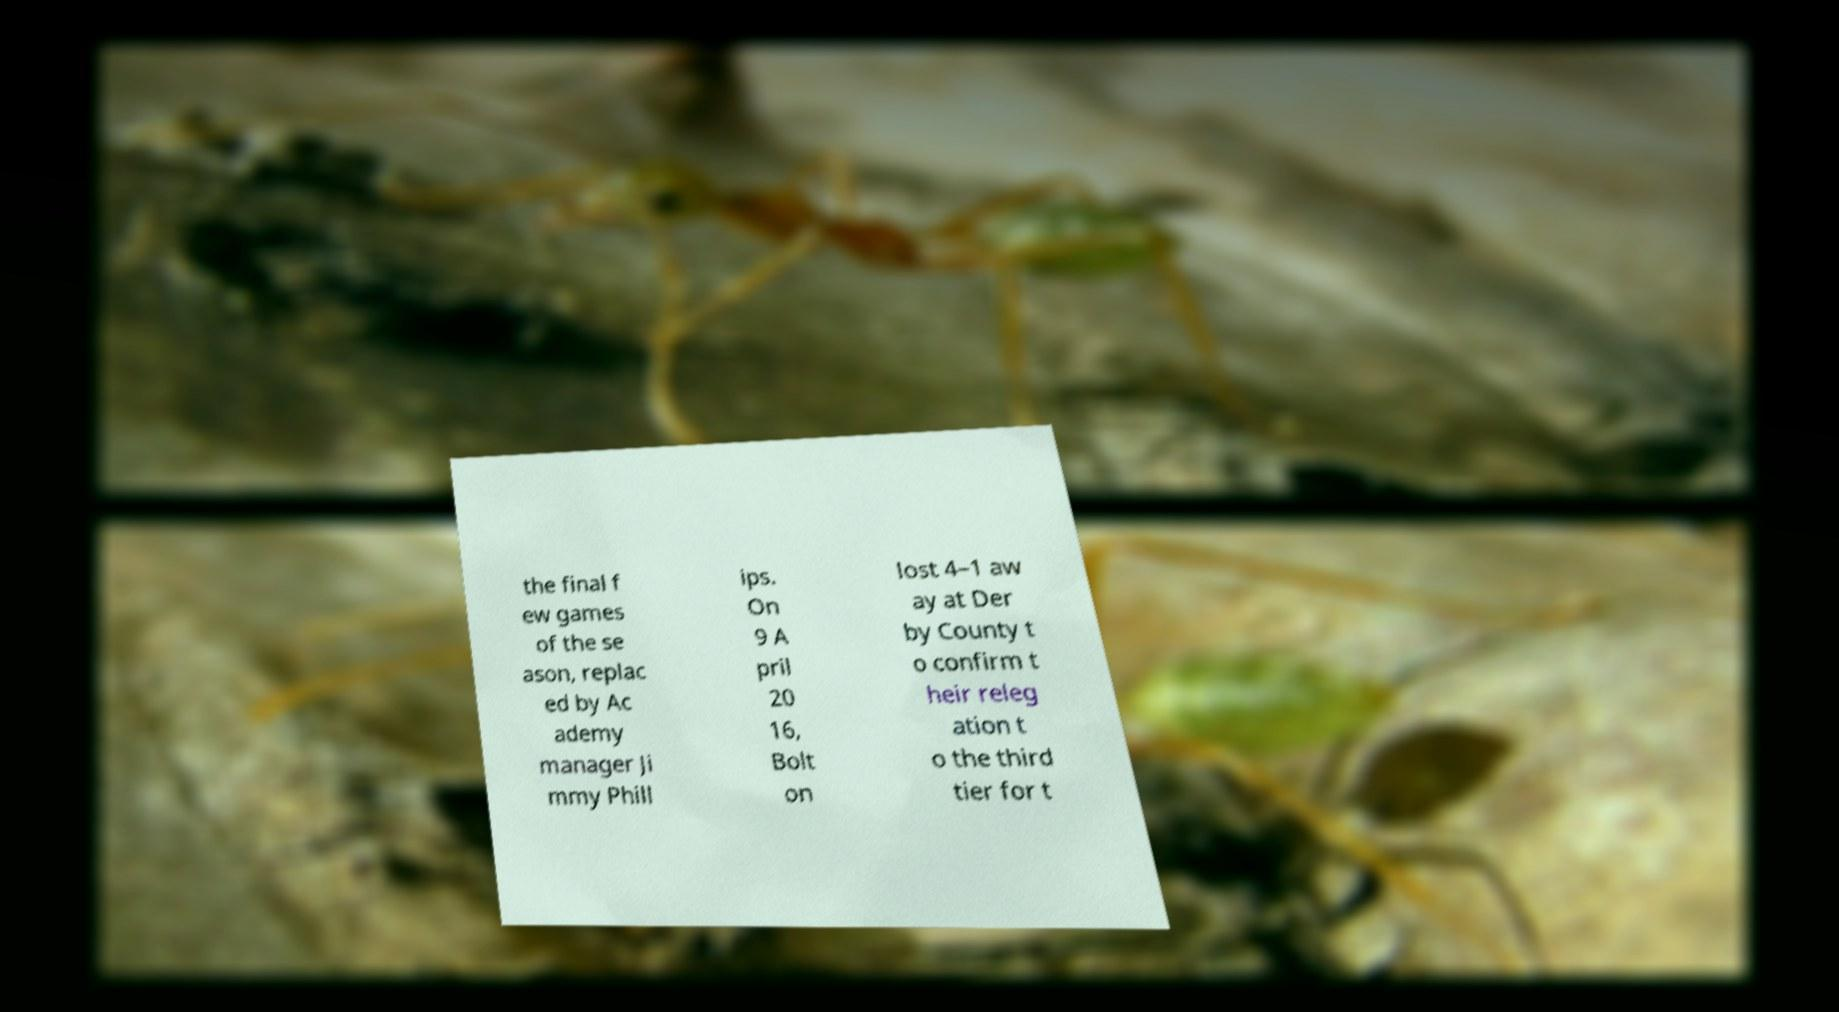For documentation purposes, I need the text within this image transcribed. Could you provide that? the final f ew games of the se ason, replac ed by Ac ademy manager Ji mmy Phill ips. On 9 A pril 20 16, Bolt on lost 4–1 aw ay at Der by County t o confirm t heir releg ation t o the third tier for t 